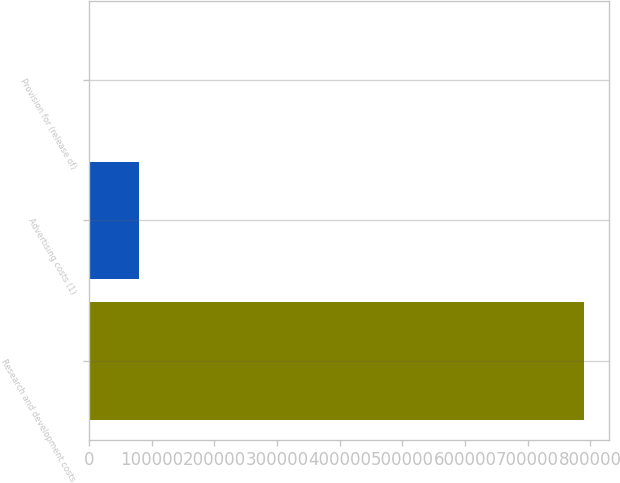Convert chart to OTSL. <chart><loc_0><loc_0><loc_500><loc_500><bar_chart><fcel>Research and development costs<fcel>Advertising costs (1)<fcel>Provision for (release of)<nl><fcel>790779<fcel>80031.9<fcel>1060<nl></chart> 